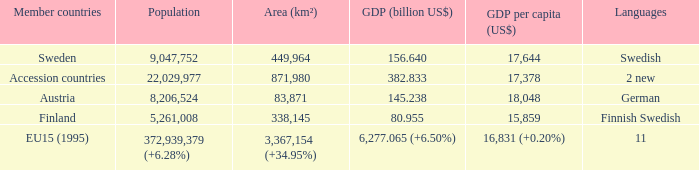Name the area for german 83871.0. 